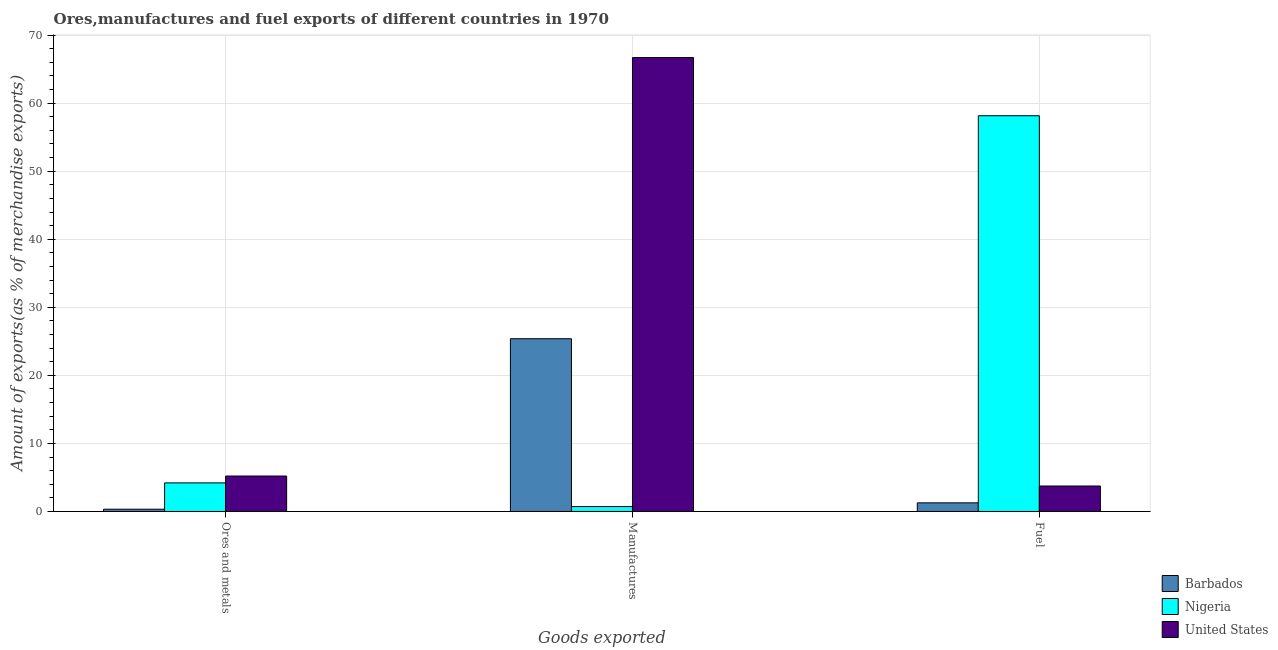How many different coloured bars are there?
Make the answer very short. 3. Are the number of bars on each tick of the X-axis equal?
Provide a short and direct response. Yes. How many bars are there on the 2nd tick from the left?
Offer a terse response. 3. What is the label of the 1st group of bars from the left?
Your response must be concise. Ores and metals. What is the percentage of fuel exports in United States?
Offer a terse response. 3.74. Across all countries, what is the maximum percentage of fuel exports?
Your response must be concise. 58.15. Across all countries, what is the minimum percentage of manufactures exports?
Make the answer very short. 0.72. In which country was the percentage of ores and metals exports minimum?
Offer a very short reply. Barbados. What is the total percentage of fuel exports in the graph?
Your answer should be very brief. 63.16. What is the difference between the percentage of ores and metals exports in United States and that in Barbados?
Your answer should be very brief. 4.87. What is the difference between the percentage of fuel exports in Barbados and the percentage of manufactures exports in United States?
Your response must be concise. -65.43. What is the average percentage of ores and metals exports per country?
Offer a very short reply. 3.25. What is the difference between the percentage of fuel exports and percentage of manufactures exports in Nigeria?
Keep it short and to the point. 57.42. In how many countries, is the percentage of manufactures exports greater than 36 %?
Provide a succinct answer. 1. What is the ratio of the percentage of ores and metals exports in Barbados to that in United States?
Your answer should be very brief. 0.06. Is the percentage of ores and metals exports in Barbados less than that in Nigeria?
Your answer should be compact. Yes. What is the difference between the highest and the second highest percentage of fuel exports?
Ensure brevity in your answer.  54.4. What is the difference between the highest and the lowest percentage of fuel exports?
Your answer should be compact. 56.88. In how many countries, is the percentage of manufactures exports greater than the average percentage of manufactures exports taken over all countries?
Your answer should be very brief. 1. What does the 1st bar from the left in Fuel represents?
Give a very brief answer. Barbados. What does the 2nd bar from the right in Ores and metals represents?
Your response must be concise. Nigeria. Is it the case that in every country, the sum of the percentage of ores and metals exports and percentage of manufactures exports is greater than the percentage of fuel exports?
Your answer should be compact. No. Are all the bars in the graph horizontal?
Your response must be concise. No. How are the legend labels stacked?
Make the answer very short. Vertical. What is the title of the graph?
Offer a terse response. Ores,manufactures and fuel exports of different countries in 1970. What is the label or title of the X-axis?
Offer a very short reply. Goods exported. What is the label or title of the Y-axis?
Your answer should be very brief. Amount of exports(as % of merchandise exports). What is the Amount of exports(as % of merchandise exports) in Barbados in Ores and metals?
Provide a succinct answer. 0.34. What is the Amount of exports(as % of merchandise exports) of Nigeria in Ores and metals?
Your response must be concise. 4.2. What is the Amount of exports(as % of merchandise exports) in United States in Ores and metals?
Your answer should be very brief. 5.21. What is the Amount of exports(as % of merchandise exports) of Barbados in Manufactures?
Make the answer very short. 25.38. What is the Amount of exports(as % of merchandise exports) in Nigeria in Manufactures?
Ensure brevity in your answer.  0.72. What is the Amount of exports(as % of merchandise exports) in United States in Manufactures?
Make the answer very short. 66.7. What is the Amount of exports(as % of merchandise exports) in Barbados in Fuel?
Make the answer very short. 1.27. What is the Amount of exports(as % of merchandise exports) of Nigeria in Fuel?
Keep it short and to the point. 58.15. What is the Amount of exports(as % of merchandise exports) of United States in Fuel?
Offer a terse response. 3.74. Across all Goods exported, what is the maximum Amount of exports(as % of merchandise exports) of Barbados?
Provide a short and direct response. 25.38. Across all Goods exported, what is the maximum Amount of exports(as % of merchandise exports) in Nigeria?
Your answer should be compact. 58.15. Across all Goods exported, what is the maximum Amount of exports(as % of merchandise exports) of United States?
Provide a short and direct response. 66.7. Across all Goods exported, what is the minimum Amount of exports(as % of merchandise exports) of Barbados?
Your answer should be very brief. 0.34. Across all Goods exported, what is the minimum Amount of exports(as % of merchandise exports) of Nigeria?
Make the answer very short. 0.72. Across all Goods exported, what is the minimum Amount of exports(as % of merchandise exports) of United States?
Provide a short and direct response. 3.74. What is the total Amount of exports(as % of merchandise exports) of Barbados in the graph?
Ensure brevity in your answer.  26.99. What is the total Amount of exports(as % of merchandise exports) in Nigeria in the graph?
Give a very brief answer. 63.07. What is the total Amount of exports(as % of merchandise exports) of United States in the graph?
Offer a very short reply. 75.65. What is the difference between the Amount of exports(as % of merchandise exports) in Barbados in Ores and metals and that in Manufactures?
Offer a terse response. -25.05. What is the difference between the Amount of exports(as % of merchandise exports) of Nigeria in Ores and metals and that in Manufactures?
Give a very brief answer. 3.48. What is the difference between the Amount of exports(as % of merchandise exports) in United States in Ores and metals and that in Manufactures?
Your answer should be very brief. -61.48. What is the difference between the Amount of exports(as % of merchandise exports) of Barbados in Ores and metals and that in Fuel?
Keep it short and to the point. -0.93. What is the difference between the Amount of exports(as % of merchandise exports) in Nigeria in Ores and metals and that in Fuel?
Your answer should be very brief. -53.95. What is the difference between the Amount of exports(as % of merchandise exports) in United States in Ores and metals and that in Fuel?
Give a very brief answer. 1.47. What is the difference between the Amount of exports(as % of merchandise exports) in Barbados in Manufactures and that in Fuel?
Offer a very short reply. 24.11. What is the difference between the Amount of exports(as % of merchandise exports) in Nigeria in Manufactures and that in Fuel?
Your answer should be very brief. -57.42. What is the difference between the Amount of exports(as % of merchandise exports) of United States in Manufactures and that in Fuel?
Offer a very short reply. 62.95. What is the difference between the Amount of exports(as % of merchandise exports) in Barbados in Ores and metals and the Amount of exports(as % of merchandise exports) in Nigeria in Manufactures?
Ensure brevity in your answer.  -0.39. What is the difference between the Amount of exports(as % of merchandise exports) of Barbados in Ores and metals and the Amount of exports(as % of merchandise exports) of United States in Manufactures?
Your answer should be very brief. -66.36. What is the difference between the Amount of exports(as % of merchandise exports) in Nigeria in Ores and metals and the Amount of exports(as % of merchandise exports) in United States in Manufactures?
Offer a very short reply. -62.49. What is the difference between the Amount of exports(as % of merchandise exports) in Barbados in Ores and metals and the Amount of exports(as % of merchandise exports) in Nigeria in Fuel?
Your answer should be very brief. -57.81. What is the difference between the Amount of exports(as % of merchandise exports) in Barbados in Ores and metals and the Amount of exports(as % of merchandise exports) in United States in Fuel?
Give a very brief answer. -3.41. What is the difference between the Amount of exports(as % of merchandise exports) of Nigeria in Ores and metals and the Amount of exports(as % of merchandise exports) of United States in Fuel?
Offer a terse response. 0.46. What is the difference between the Amount of exports(as % of merchandise exports) of Barbados in Manufactures and the Amount of exports(as % of merchandise exports) of Nigeria in Fuel?
Your answer should be very brief. -32.76. What is the difference between the Amount of exports(as % of merchandise exports) in Barbados in Manufactures and the Amount of exports(as % of merchandise exports) in United States in Fuel?
Ensure brevity in your answer.  21.64. What is the difference between the Amount of exports(as % of merchandise exports) in Nigeria in Manufactures and the Amount of exports(as % of merchandise exports) in United States in Fuel?
Offer a very short reply. -3.02. What is the average Amount of exports(as % of merchandise exports) of Barbados per Goods exported?
Ensure brevity in your answer.  9. What is the average Amount of exports(as % of merchandise exports) in Nigeria per Goods exported?
Your response must be concise. 21.02. What is the average Amount of exports(as % of merchandise exports) of United States per Goods exported?
Your response must be concise. 25.22. What is the difference between the Amount of exports(as % of merchandise exports) of Barbados and Amount of exports(as % of merchandise exports) of Nigeria in Ores and metals?
Your response must be concise. -3.86. What is the difference between the Amount of exports(as % of merchandise exports) of Barbados and Amount of exports(as % of merchandise exports) of United States in Ores and metals?
Offer a terse response. -4.87. What is the difference between the Amount of exports(as % of merchandise exports) in Nigeria and Amount of exports(as % of merchandise exports) in United States in Ores and metals?
Keep it short and to the point. -1.01. What is the difference between the Amount of exports(as % of merchandise exports) of Barbados and Amount of exports(as % of merchandise exports) of Nigeria in Manufactures?
Provide a succinct answer. 24.66. What is the difference between the Amount of exports(as % of merchandise exports) of Barbados and Amount of exports(as % of merchandise exports) of United States in Manufactures?
Your response must be concise. -41.31. What is the difference between the Amount of exports(as % of merchandise exports) in Nigeria and Amount of exports(as % of merchandise exports) in United States in Manufactures?
Offer a terse response. -65.97. What is the difference between the Amount of exports(as % of merchandise exports) in Barbados and Amount of exports(as % of merchandise exports) in Nigeria in Fuel?
Make the answer very short. -56.88. What is the difference between the Amount of exports(as % of merchandise exports) in Barbados and Amount of exports(as % of merchandise exports) in United States in Fuel?
Give a very brief answer. -2.48. What is the difference between the Amount of exports(as % of merchandise exports) of Nigeria and Amount of exports(as % of merchandise exports) of United States in Fuel?
Provide a succinct answer. 54.4. What is the ratio of the Amount of exports(as % of merchandise exports) of Barbados in Ores and metals to that in Manufactures?
Offer a terse response. 0.01. What is the ratio of the Amount of exports(as % of merchandise exports) of Nigeria in Ores and metals to that in Manufactures?
Offer a terse response. 5.8. What is the ratio of the Amount of exports(as % of merchandise exports) in United States in Ores and metals to that in Manufactures?
Keep it short and to the point. 0.08. What is the ratio of the Amount of exports(as % of merchandise exports) in Barbados in Ores and metals to that in Fuel?
Keep it short and to the point. 0.27. What is the ratio of the Amount of exports(as % of merchandise exports) in Nigeria in Ores and metals to that in Fuel?
Your answer should be very brief. 0.07. What is the ratio of the Amount of exports(as % of merchandise exports) in United States in Ores and metals to that in Fuel?
Your response must be concise. 1.39. What is the ratio of the Amount of exports(as % of merchandise exports) in Barbados in Manufactures to that in Fuel?
Provide a short and direct response. 20. What is the ratio of the Amount of exports(as % of merchandise exports) of Nigeria in Manufactures to that in Fuel?
Make the answer very short. 0.01. What is the ratio of the Amount of exports(as % of merchandise exports) of United States in Manufactures to that in Fuel?
Provide a short and direct response. 17.81. What is the difference between the highest and the second highest Amount of exports(as % of merchandise exports) of Barbados?
Ensure brevity in your answer.  24.11. What is the difference between the highest and the second highest Amount of exports(as % of merchandise exports) in Nigeria?
Ensure brevity in your answer.  53.95. What is the difference between the highest and the second highest Amount of exports(as % of merchandise exports) in United States?
Your answer should be very brief. 61.48. What is the difference between the highest and the lowest Amount of exports(as % of merchandise exports) in Barbados?
Make the answer very short. 25.05. What is the difference between the highest and the lowest Amount of exports(as % of merchandise exports) of Nigeria?
Your answer should be very brief. 57.42. What is the difference between the highest and the lowest Amount of exports(as % of merchandise exports) in United States?
Your answer should be compact. 62.95. 